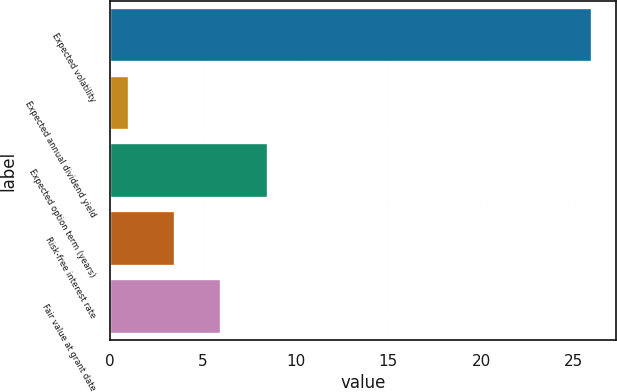<chart> <loc_0><loc_0><loc_500><loc_500><bar_chart><fcel>Expected volatility<fcel>Expected annual dividend yield<fcel>Expected option term (years)<fcel>Risk-free interest rate<fcel>Fair value at grant date<nl><fcel>26<fcel>1<fcel>8.5<fcel>3.5<fcel>6<nl></chart> 